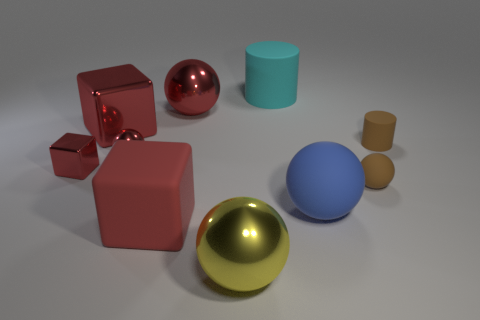How many red blocks must be subtracted to get 1 red blocks? 2 Subtract all large matte spheres. How many spheres are left? 4 Subtract all yellow balls. How many balls are left? 4 Subtract all purple balls. Subtract all brown cubes. How many balls are left? 5 Subtract all cubes. How many objects are left? 7 Subtract 2 red spheres. How many objects are left? 8 Subtract all cyan cylinders. Subtract all cyan things. How many objects are left? 8 Add 8 big blue matte balls. How many big blue matte balls are left? 9 Add 3 red things. How many red things exist? 8 